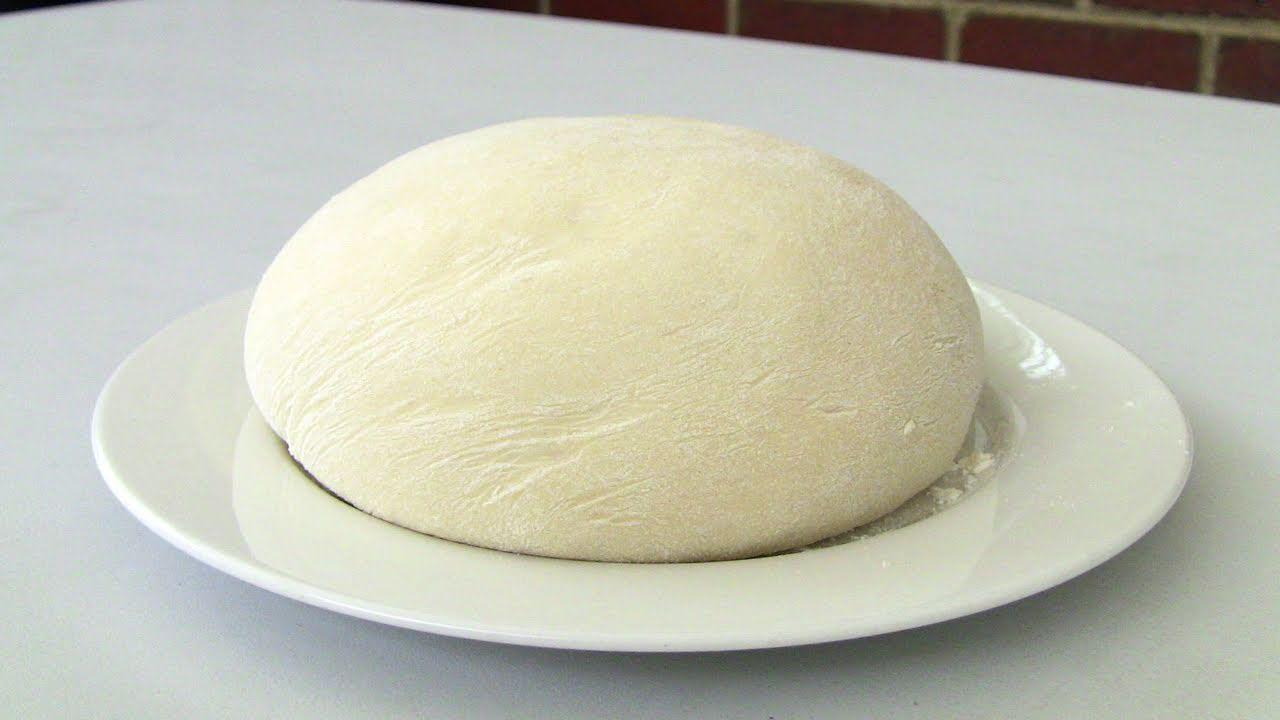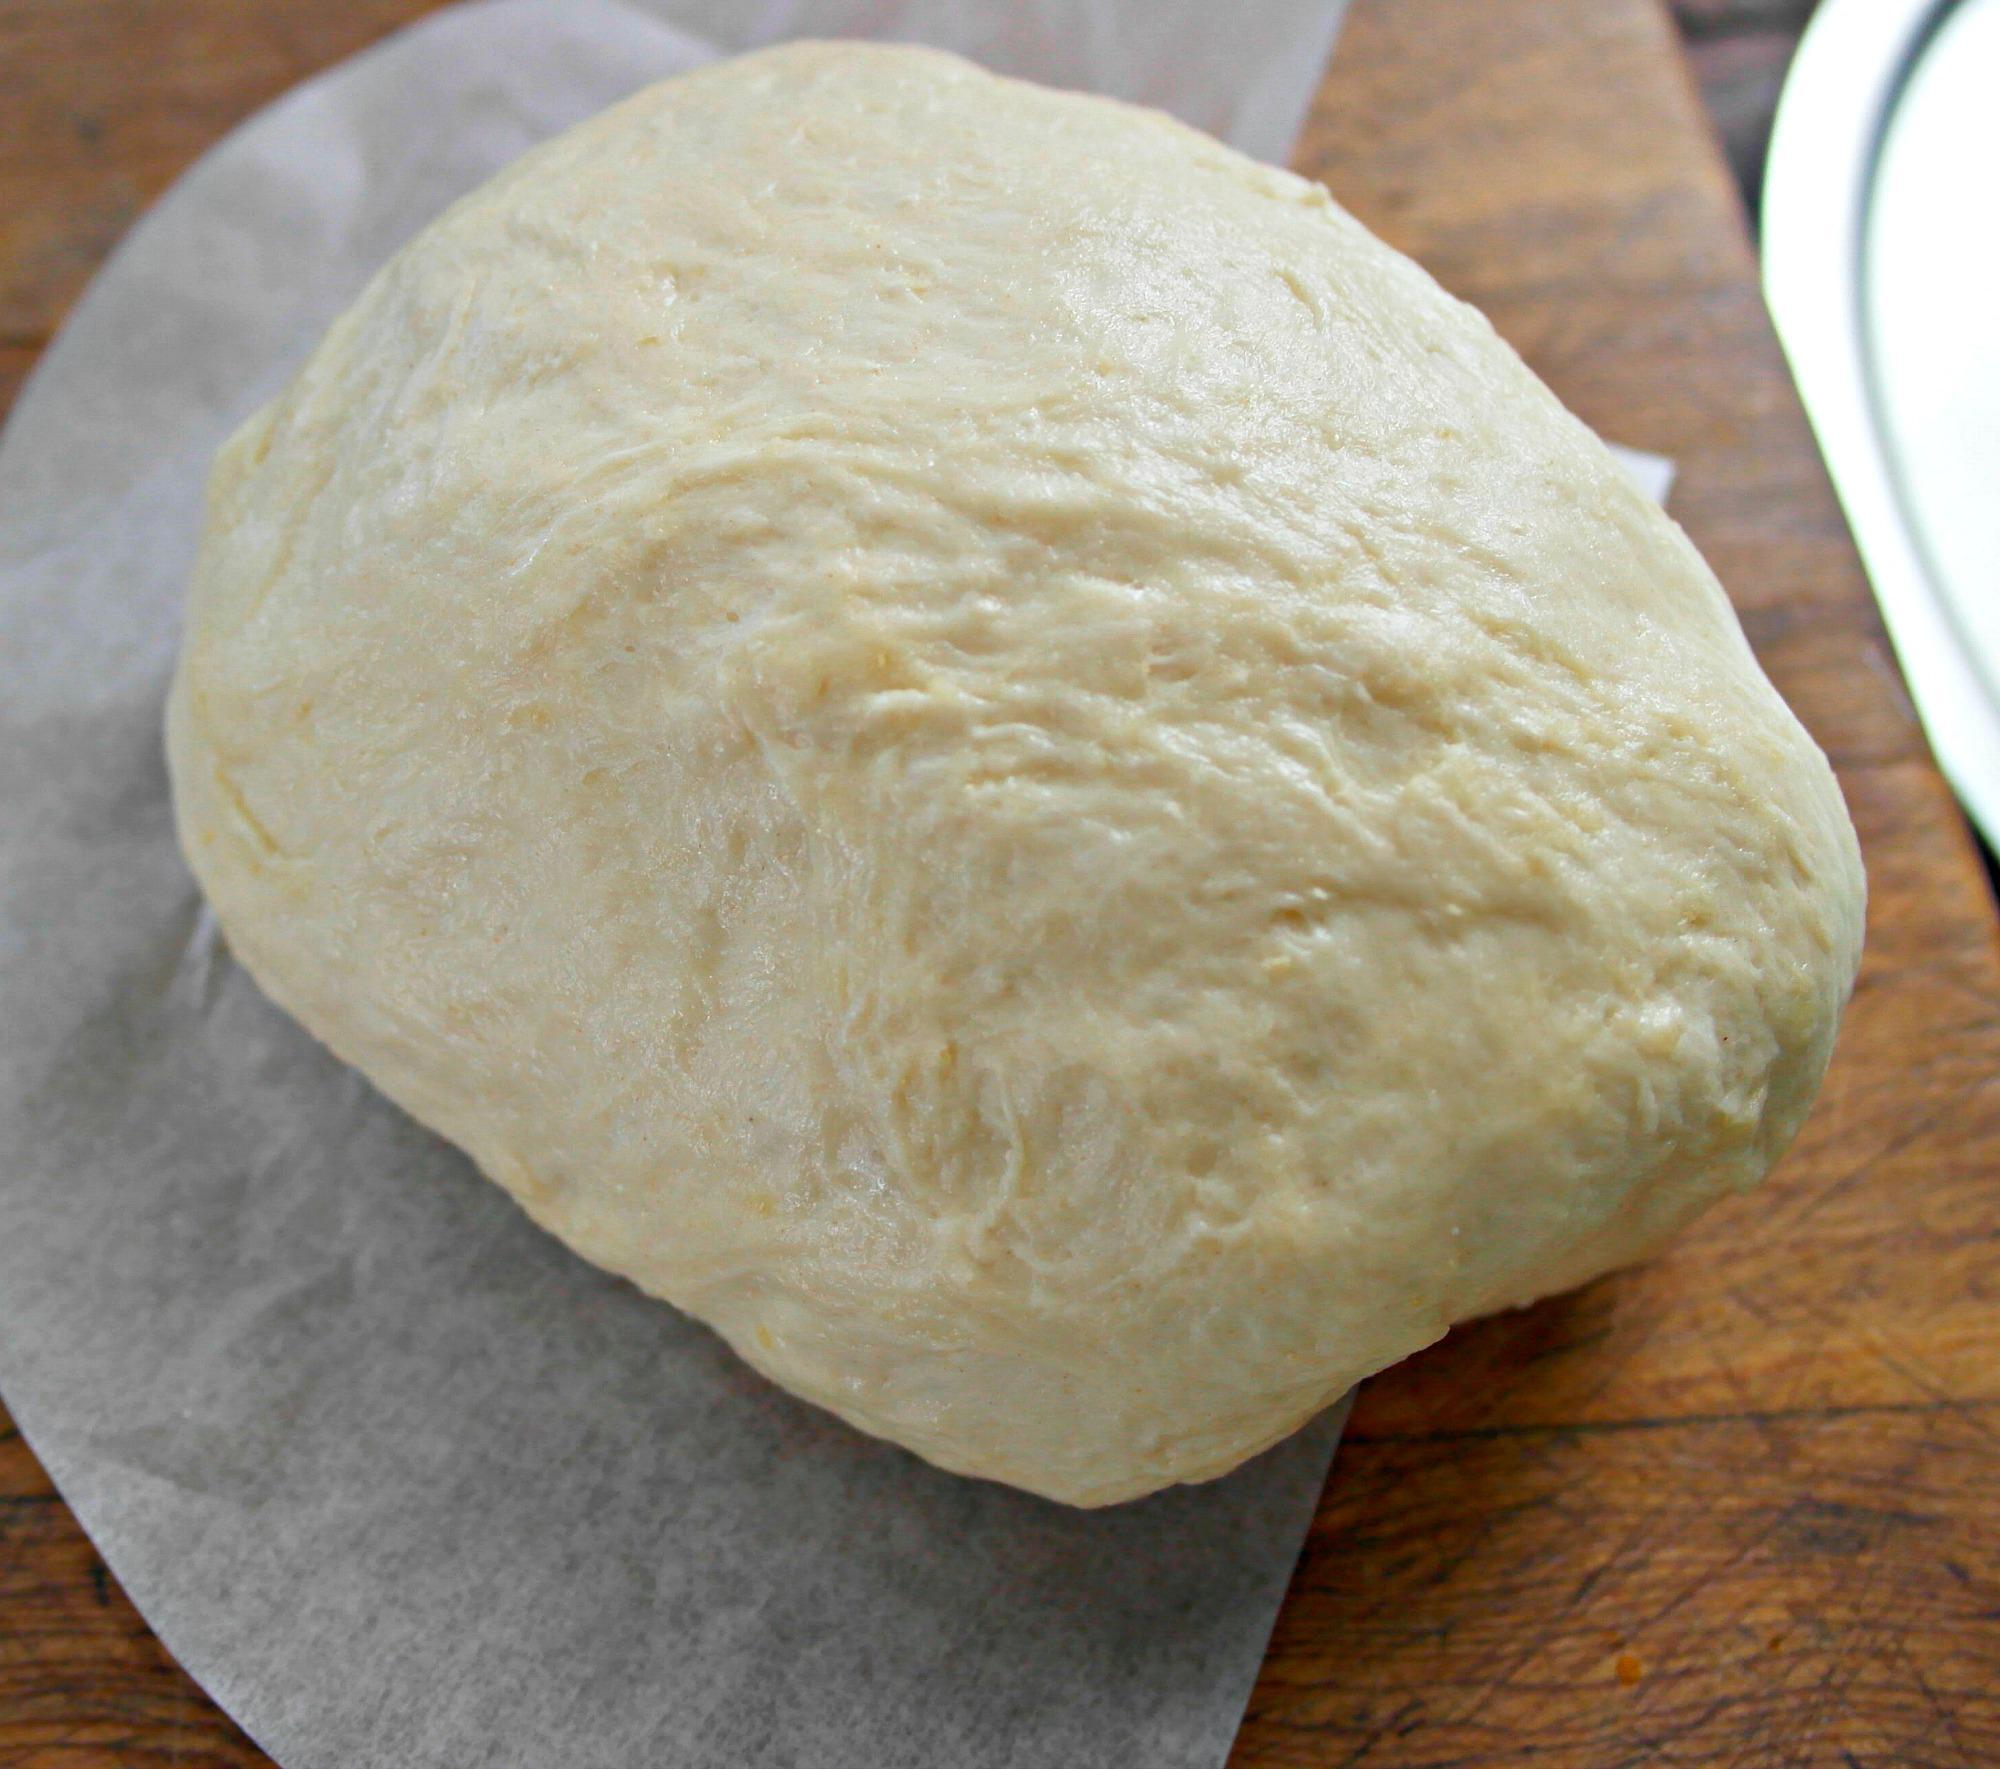The first image is the image on the left, the second image is the image on the right. Considering the images on both sides, is "One piece of dough is flattened." valid? Answer yes or no. No. The first image is the image on the left, the second image is the image on the right. For the images displayed, is the sentence "The right image shows at least three round mounds of dough on floured brown paper." factually correct? Answer yes or no. No. 